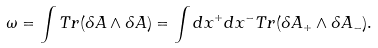Convert formula to latex. <formula><loc_0><loc_0><loc_500><loc_500>\omega = \int T r ( \delta A \wedge \delta A ) = \int d x ^ { + } d x ^ { - } T r ( \delta A _ { + } \wedge \delta A _ { - } ) .</formula> 